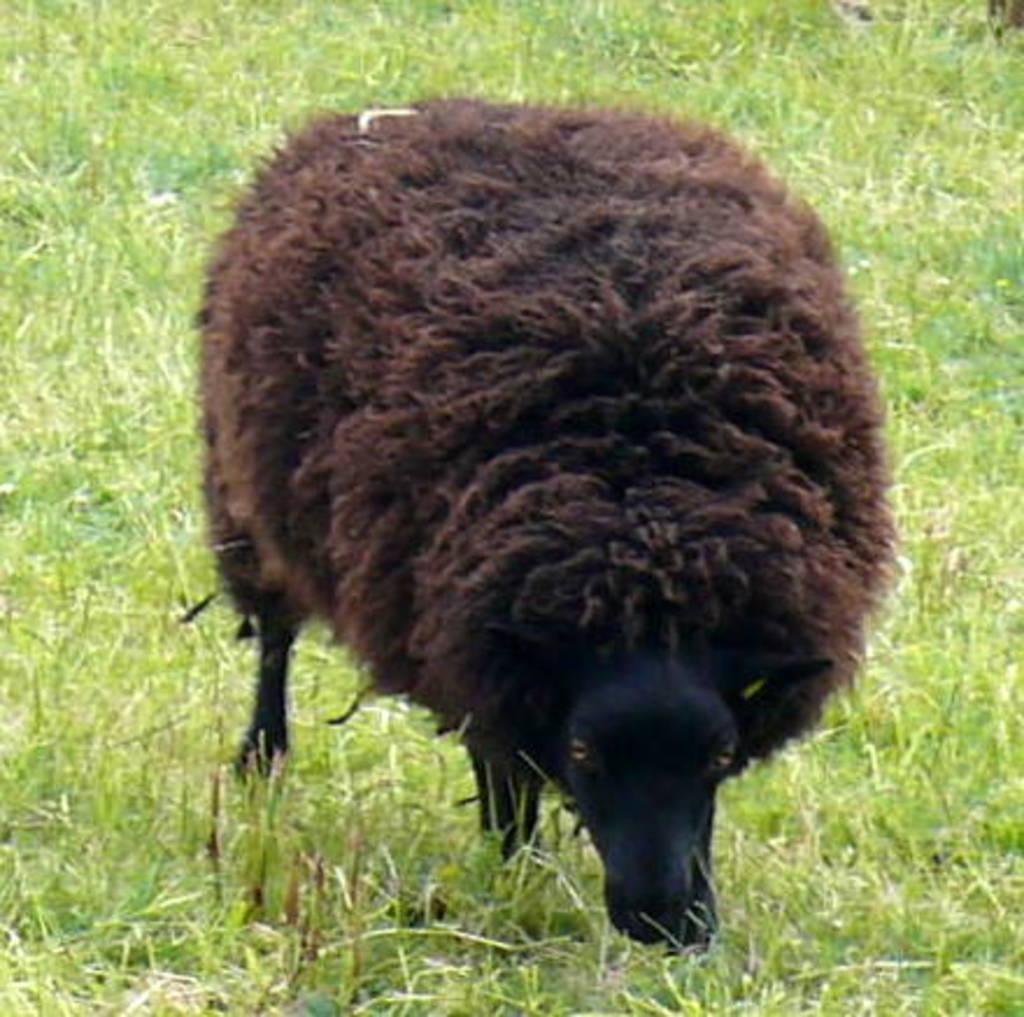How would you summarize this image in a sentence or two? In this image we can see a sheep is standing on the grass. 